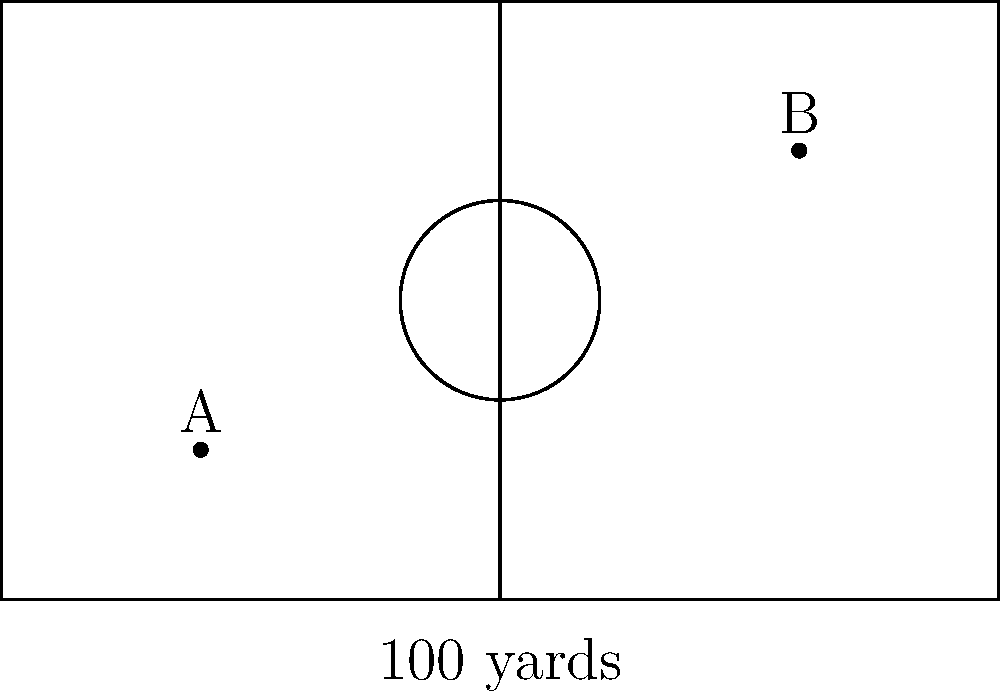During a match at CS Dante Botoșani's home ground, you noticed two players, one at point A (20 yards, 15 yards) and another at point B (80 yards, 45 yards) on the field. Calculate the direct distance between these two players. Round your answer to the nearest yard. To find the distance between two points, we can use the distance formula derived from the Pythagorean theorem:

$$d = \sqrt{(x_2-x_1)^2 + (y_2-y_1)^2}$$

Where $(x_1,y_1)$ are the coordinates of point A and $(x_2,y_2)$ are the coordinates of point B.

Given:
- Point A: $(20, 15)$
- Point B: $(80, 45)$

Let's substitute these values into the formula:

$$\begin{align}
d &= \sqrt{(80-20)^2 + (45-15)^2} \\
&= \sqrt{60^2 + 30^2} \\
&= \sqrt{3600 + 900} \\
&= \sqrt{4500} \\
&\approx 67.08 \text{ yards}
\end{align}$$

Rounding to the nearest yard, we get 67 yards.
Answer: 67 yards 